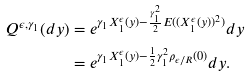<formula> <loc_0><loc_0><loc_500><loc_500>Q ^ { \epsilon , \gamma _ { 1 } } ( d y ) & = e ^ { \gamma _ { 1 } X _ { 1 } ^ { \epsilon } ( y ) - \frac { \gamma _ { 1 } ^ { 2 } } { 2 } E ( ( X _ { 1 } ^ { \epsilon } ( y ) ) ^ { 2 } ) } d y \\ & = e ^ { \gamma _ { 1 } X _ { 1 } ^ { \epsilon } ( y ) - \frac { 1 } { 2 } \gamma _ { 1 } ^ { 2 } \rho _ { \epsilon / R } ( 0 ) } d y .</formula> 